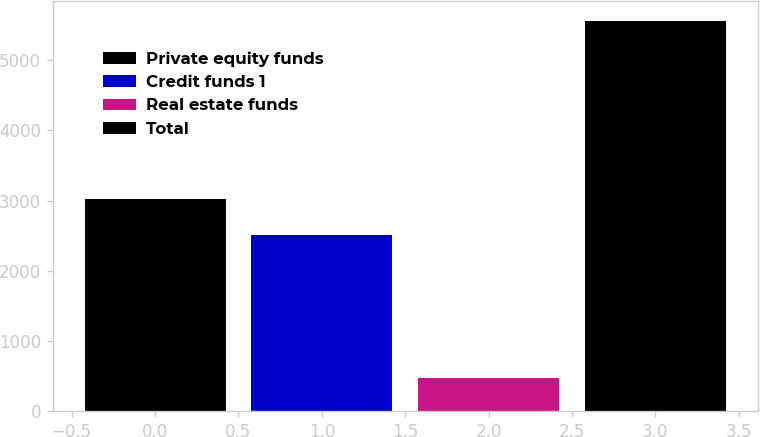Convert chart. <chart><loc_0><loc_0><loc_500><loc_500><bar_chart><fcel>Private equity funds<fcel>Credit funds 1<fcel>Real estate funds<fcel>Total<nl><fcel>3024<fcel>2515<fcel>471<fcel>5561<nl></chart> 